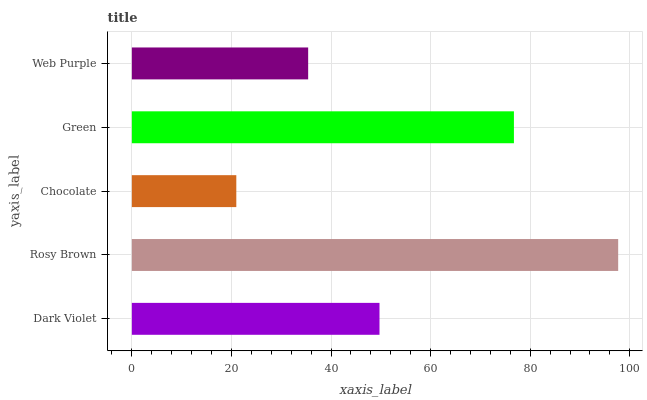Is Chocolate the minimum?
Answer yes or no. Yes. Is Rosy Brown the maximum?
Answer yes or no. Yes. Is Rosy Brown the minimum?
Answer yes or no. No. Is Chocolate the maximum?
Answer yes or no. No. Is Rosy Brown greater than Chocolate?
Answer yes or no. Yes. Is Chocolate less than Rosy Brown?
Answer yes or no. Yes. Is Chocolate greater than Rosy Brown?
Answer yes or no. No. Is Rosy Brown less than Chocolate?
Answer yes or no. No. Is Dark Violet the high median?
Answer yes or no. Yes. Is Dark Violet the low median?
Answer yes or no. Yes. Is Green the high median?
Answer yes or no. No. Is Web Purple the low median?
Answer yes or no. No. 